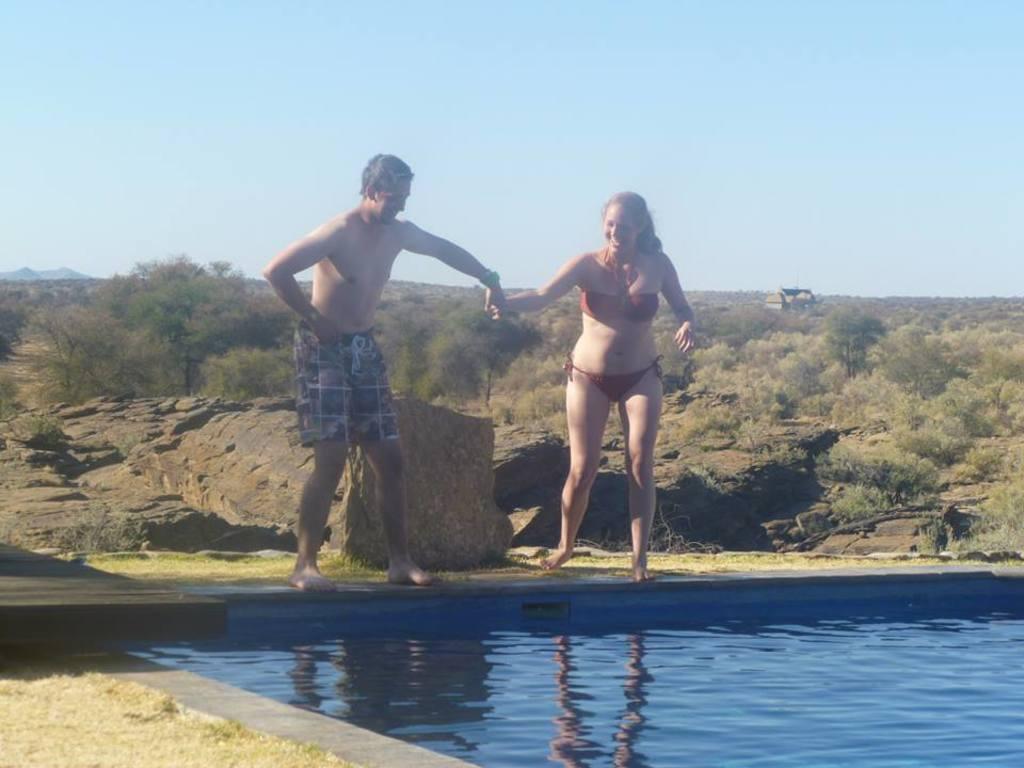How would you summarize this image in a sentence or two? There is a person in a short smiling, standing and holding a hand of a woman who is in brown color bikini and is smiling and standing on the floor near a swimming pool which is having blue color water. In the background, there are rocks on the hill, there are trees and plants on the ground and there is blue sky. 